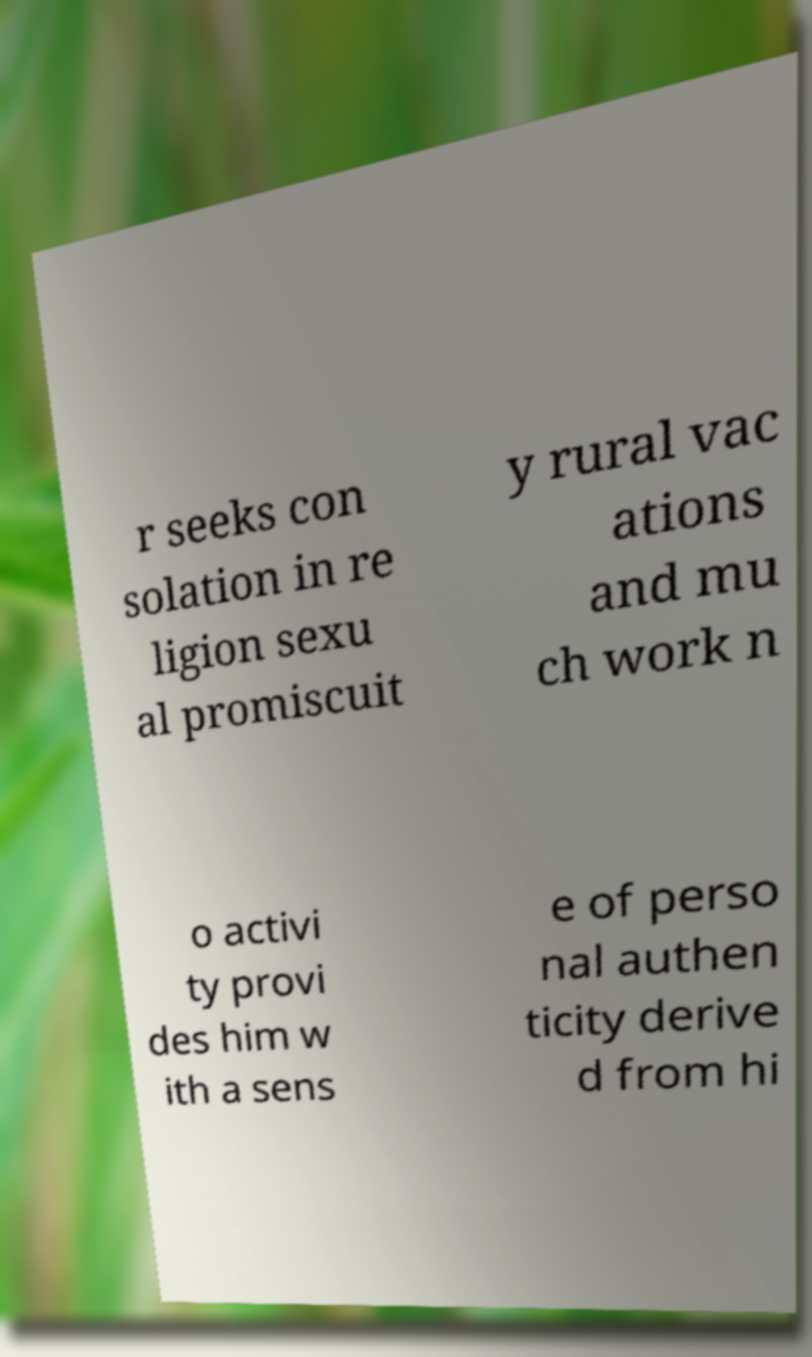Can you accurately transcribe the text from the provided image for me? r seeks con solation in re ligion sexu al promiscuit y rural vac ations and mu ch work n o activi ty provi des him w ith a sens e of perso nal authen ticity derive d from hi 